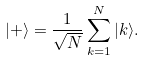<formula> <loc_0><loc_0><loc_500><loc_500>| + \rangle = \frac { 1 } { \sqrt { N } } \sum _ { k = 1 } ^ { N } | k \rangle .</formula> 